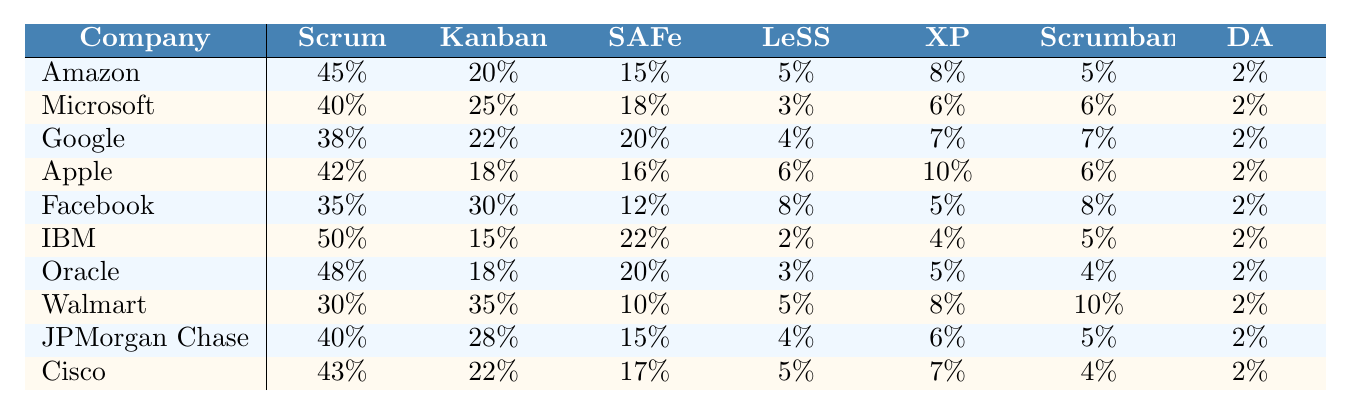What percentage of teams at IBM use Scrum? According to the table, IBM has 50% of its teams adopting Scrum.
Answer: 50% Which company has the lowest percentage of teams using SAFe? By looking at the SAFe column, Walmart has the lowest percentage with 10%.
Answer: Walmart What is the total percentage of teams at Facebook using Kanban and Scrumban? Facebook uses 30% Kanban and 8% Scrumban. Adding these gives 30% + 8% = 38%.
Answer: 38% Which company uses more Scrumban, Amazon or Oracle? Amazon uses 5% Scrumban and Oracle uses 4% Scrumban. Since 5% is greater than 4%, Amazon uses more.
Answer: Amazon What is the average percentage of teams using Extreme Programming (XP) among all companies? Summing the XP percentages: (8 + 6 + 7 + 10 + 5 + 4 + 5 + 8 + 6 + 7) gives 66%. Dividing by the number of companies (10), the average is 66% / 10 = 6.6%.
Answer: 6.6% Is it true that more than 45% of the teams at Google use Scrum? The table shows that Google uses 38% Scrum, which is less than 45%. Therefore, the statement is false.
Answer: No What is the difference in the percentage of teams using Kanban between Walmart and Microsoft? Walmart has 35% Kanban while Microsoft has 25% Kanban. The difference is 35% - 25% = 10%.
Answer: 10% Which company has the highest overall percentage of Agile framework teams when all frameworks are summed up? Summing up all percentages for IBM gives 50% + 15% + 22% + 2% + 4% + 5% + 2% = 100%. This is the highest total.
Answer: IBM What percentage of companies use less than 10% for the LeSS framework? Looking at the LeSS column, Walmart (5%) is the only company below 10%, so only one company meets this criterion.
Answer: 1 Count how many companies use more than 40% of teams with Kanban. From the Kanban column, Amazon (20%), Microsoft (25%), Google (22%), Apple (18%), Facebook (30%), and Oracle (18%) are all percentages below 40%. Consequently, it's Walmart (35%) and JPMorgan Chase (28%) that use more than 40%. Therefore, two companies meet this criterion.
Answer: 2 